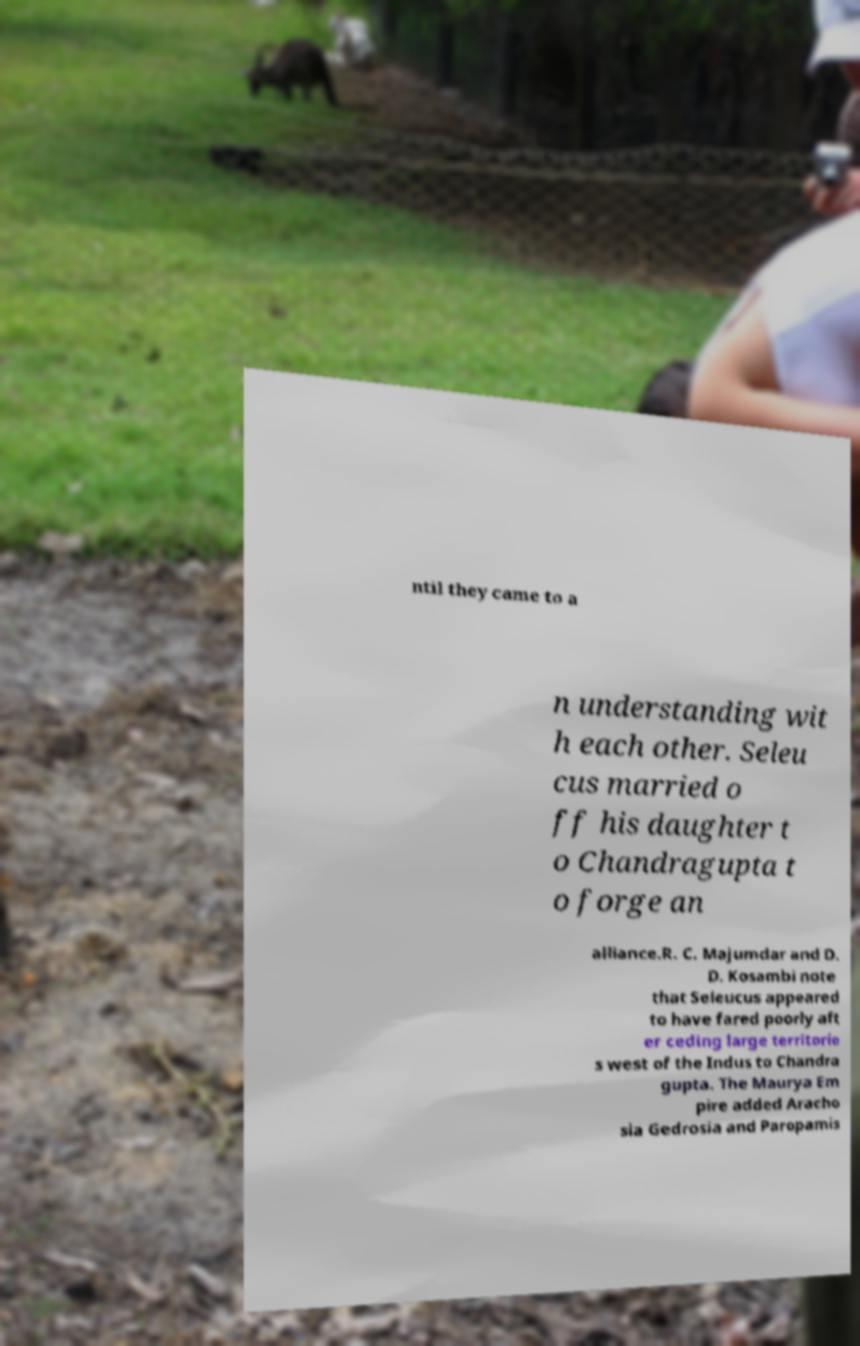Could you assist in decoding the text presented in this image and type it out clearly? ntil they came to a n understanding wit h each other. Seleu cus married o ff his daughter t o Chandragupta t o forge an alliance.R. C. Majumdar and D. D. Kosambi note that Seleucus appeared to have fared poorly aft er ceding large territorie s west of the Indus to Chandra gupta. The Maurya Em pire added Aracho sia Gedrosia and Paropamis 